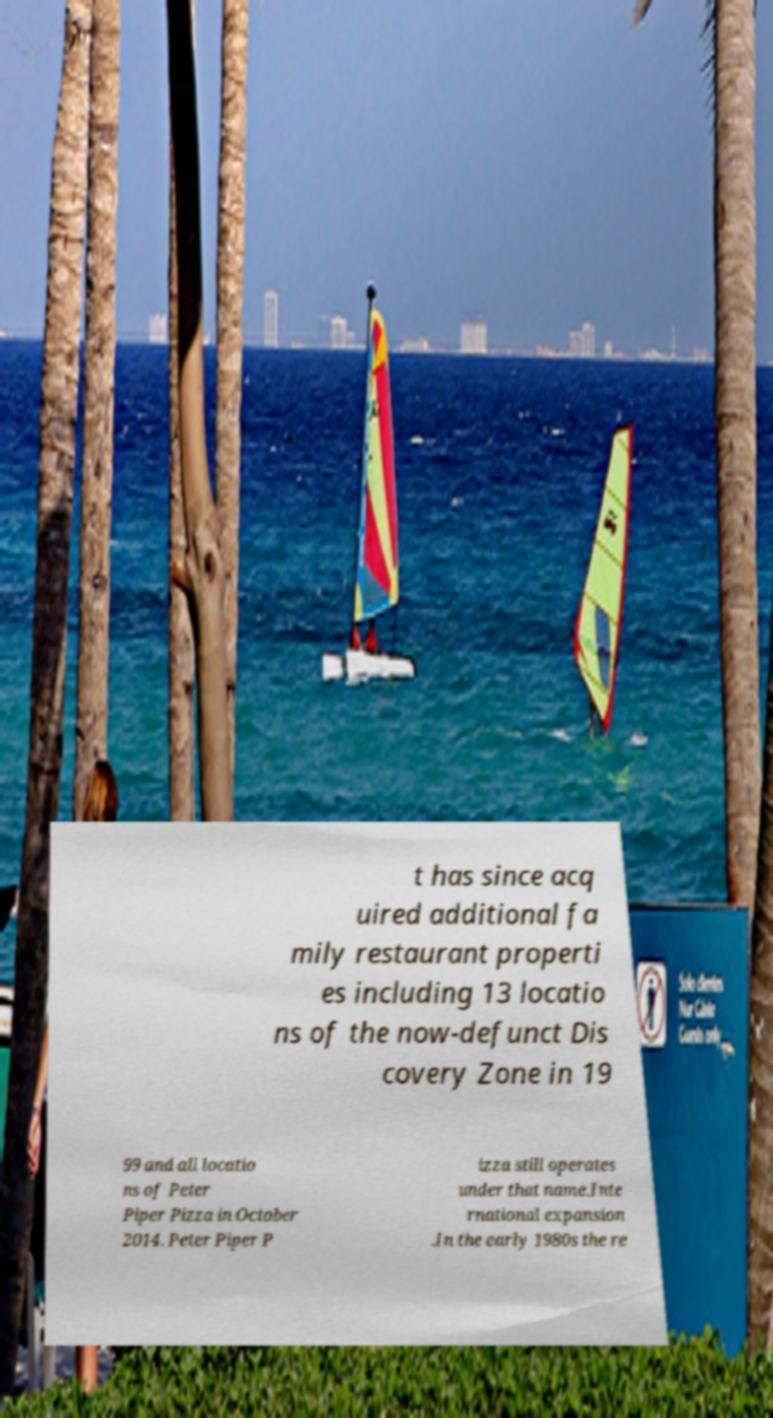Could you assist in decoding the text presented in this image and type it out clearly? t has since acq uired additional fa mily restaurant properti es including 13 locatio ns of the now-defunct Dis covery Zone in 19 99 and all locatio ns of Peter Piper Pizza in October 2014. Peter Piper P izza still operates under that name.Inte rnational expansion .In the early 1980s the re 